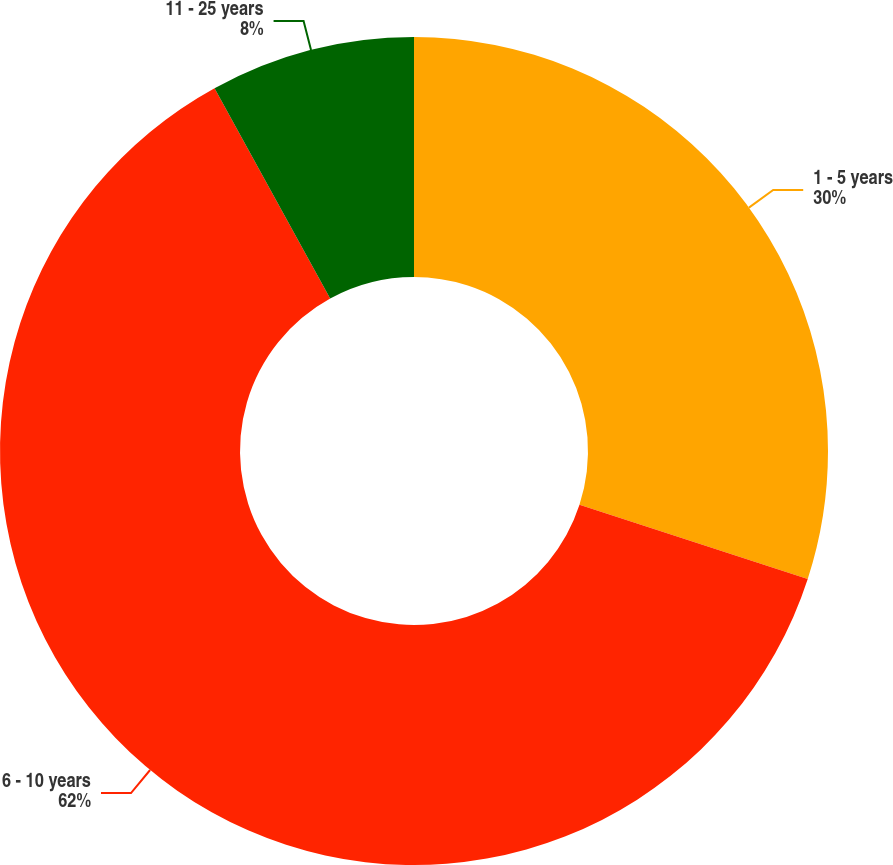<chart> <loc_0><loc_0><loc_500><loc_500><pie_chart><fcel>1 - 5 years<fcel>6 - 10 years<fcel>11 - 25 years<nl><fcel>30.0%<fcel>62.0%<fcel>8.0%<nl></chart> 